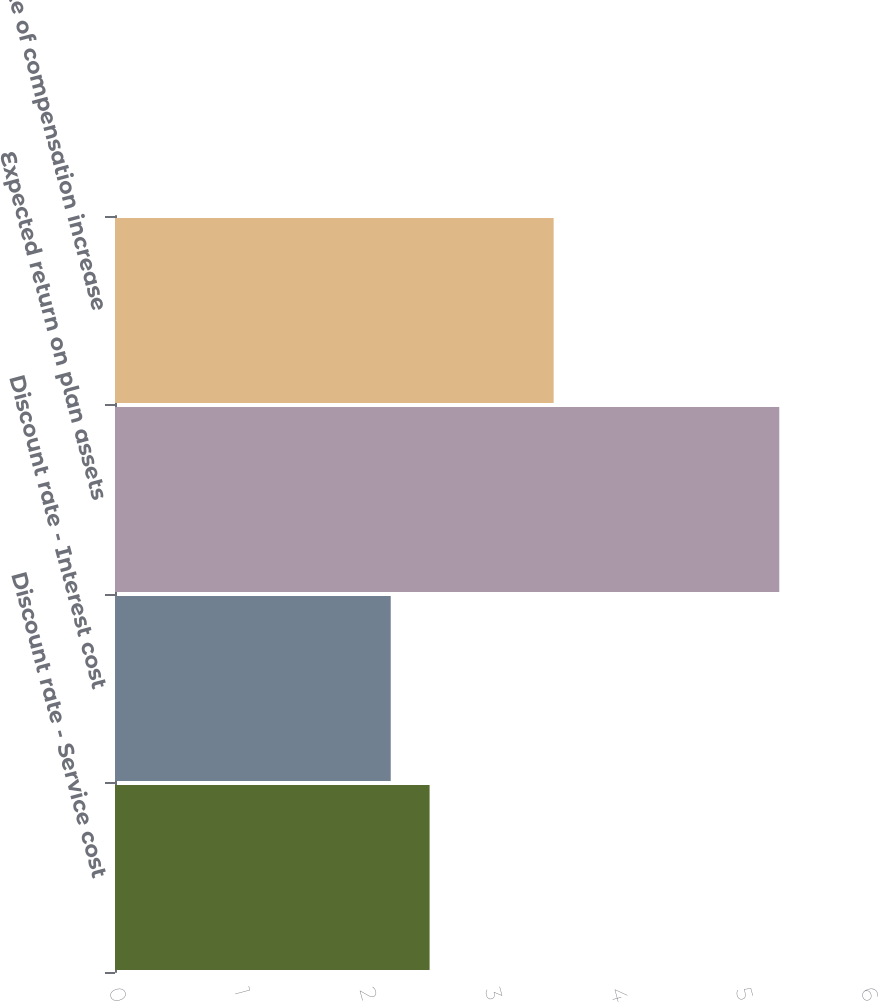Convert chart to OTSL. <chart><loc_0><loc_0><loc_500><loc_500><bar_chart><fcel>Discount rate - Service cost<fcel>Discount rate - Interest cost<fcel>Expected return on plan assets<fcel>Rate of compensation increase<nl><fcel>2.51<fcel>2.2<fcel>5.3<fcel>3.5<nl></chart> 